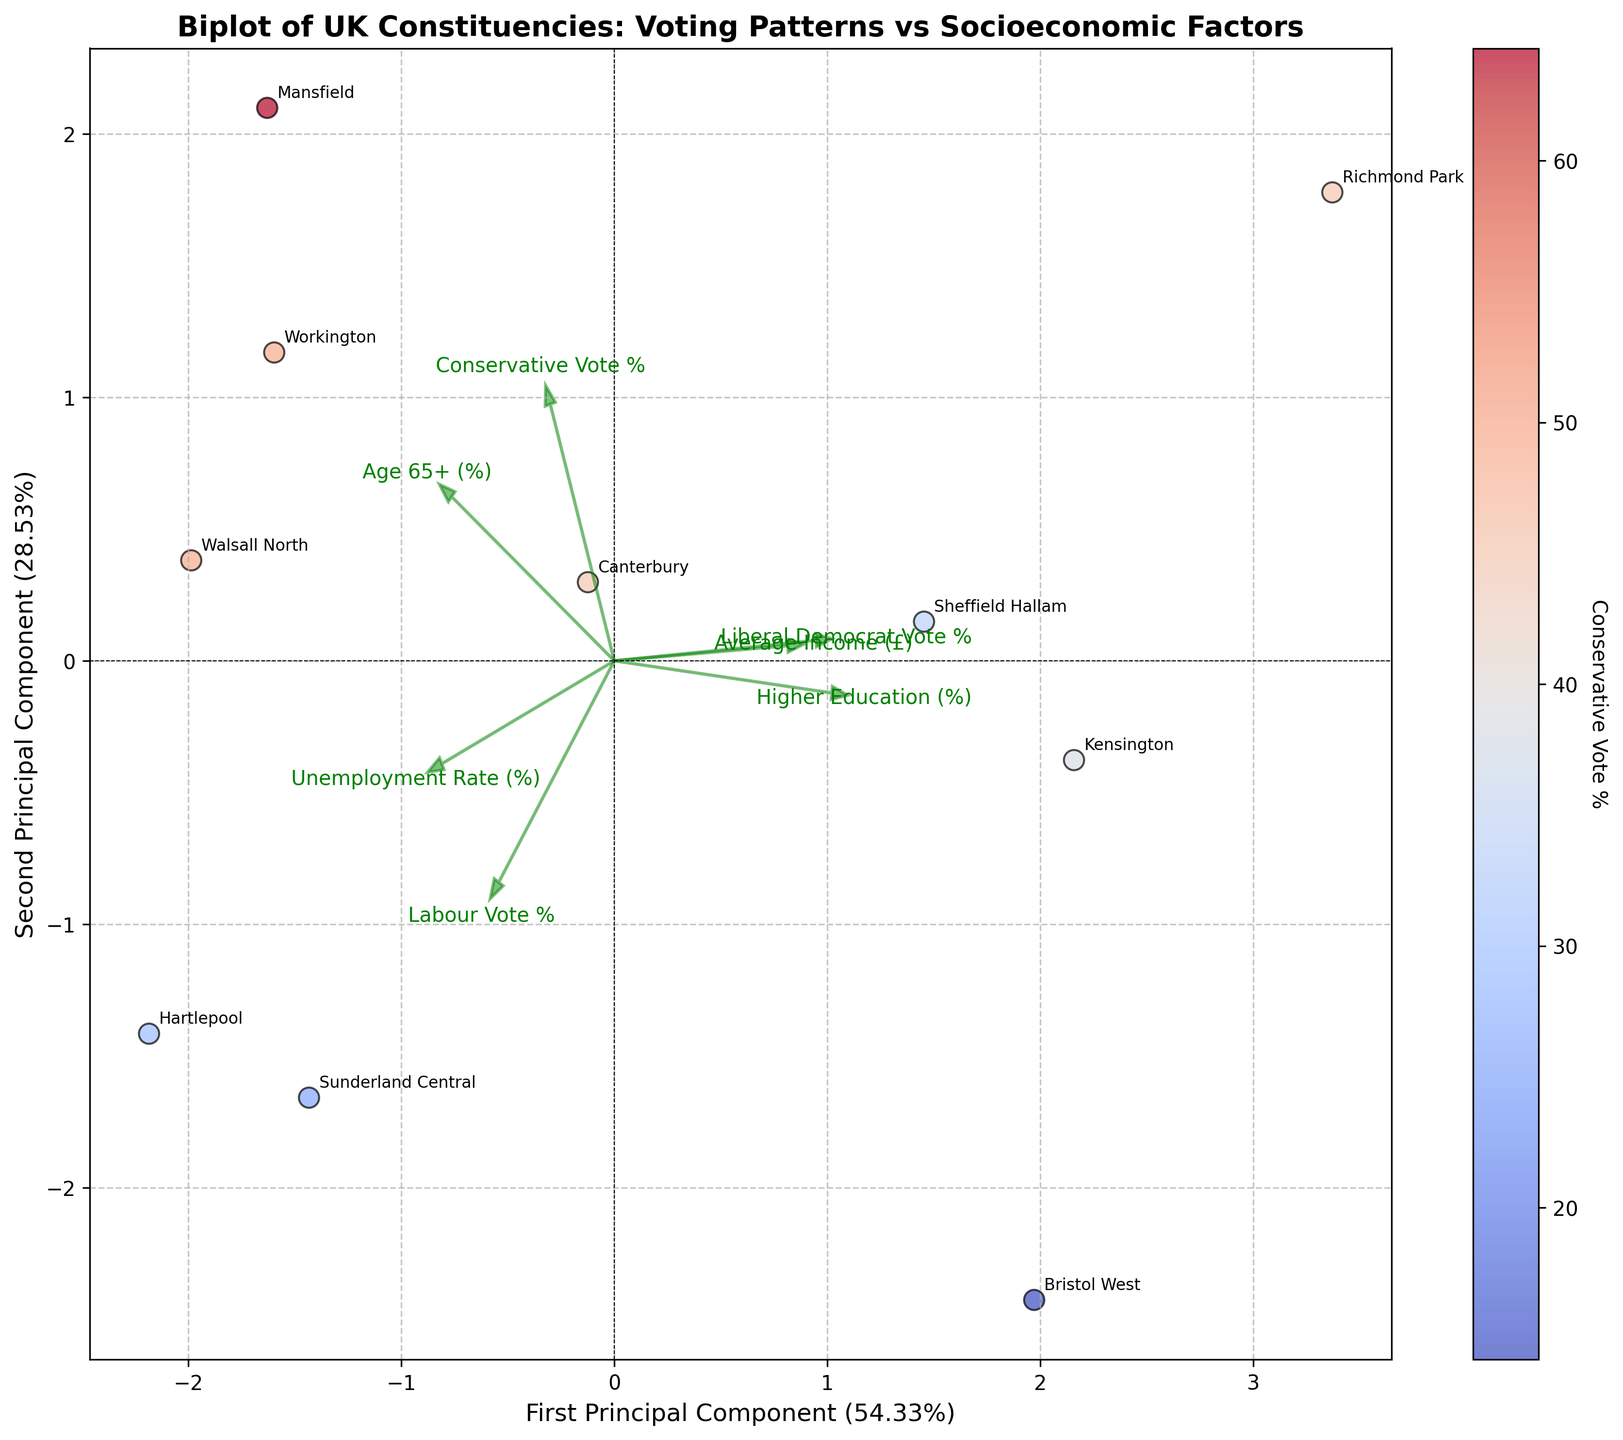What's the title of the plot? The title is usually prominently displayed at the top of the plot. This title helps to understand what the entire plot is about. The title for this plot is clearly written at the top as 'Biplot of UK Constituencies: Voting Patterns vs Socioeconomic Factors'.
Answer: Biplot of UK Constituencies: Voting Patterns vs Socioeconomic Factors How many principle components are shown on the axes? The axes are labeled with the terms 'First Principal Component' and 'Second Principal Component'. This indicates that two principal components are being visualized.
Answer: Two Which constituency has the highest Conservative Vote % based on the position on the colorbar? The colorbar indicates Conservative Vote %, which uses a color gradient. A darker color in the scatter plot corresponds to a higher Conservative Vote %. By looking at the plot, Mansfield has the highest Conservative Vote %.
Answer: Mansfield Which features are positively correlated with the First Principal Component axis? Positive correlation with the First Principal Component can be inferred from arrows pointing rightward or vectors along the positive side of the x-axis. For example, 'Conservative Vote %' and 'Higher Education (%)' arrows point in the positive direction along this axis.
Answer: Conservative Vote %, Higher Education (%) Which socioeconomic factor has the strongest influence on the First Principal Component? The length and direction of the arrows in the biplot represent the influence of a feature on a principal component. The longer the arrow, the higher the influence. The longest arrows along the First Principal Component axis indicate that 'Conservative Vote %' has the strongest influence.
Answer: Conservative Vote % Which constituency is located closest to the origin of the biplot, indicating average characteristics? Constituencies closer to the origin (where the two principal components intersect) have more average values across the considered features. By visually inspecting the plot, Sheffield Hallam is closest to the origin.
Answer: Sheffield Hallam How does the Age 65+ (%) factor relate to the socioeconomic factors and voting patterns in this biplot? The arrow for 'Age 65+ (%)' pointing slightly upward and left indicates a positive correlation with the Second Principal Component and a negative correlation with the First Principal Component. This means constituencies with a higher percentage of age 65+ generally have lower Conservative Votes % and are more influenced by other socioeconomic factors.
Answer: Higher age 65+ means lower Conservative Votes % Which constituencies have similar voting patterns according to this biplot? Constituencies that cluster together in the biplot have similar voting patterns. For example, Canterbury and Kensington appear close together, indicating similarity in their voting and socioeconomic characteristics.
Answer: Canterbury and Kensington What's the main insight provided by plotting Liberal Democrat Vote % on the biplot? The direction and length of the 'Liberal Democrat Vote %' arrow can show its correlation with the principal components. It points downwards and slightly to the right, indicating a negative correlation with the Second Principal Component and a slight positive one with the First. This suggests that Liberal Democrat Votes increase as some of the other factors decrease.
Answer: Liberal Democrats increase as some factors decrease Which feature vectors are negatively correlated with each other? Negative correlation between features can be inferred from their arrows pointing in opposite directions. For instance, 'Labour Vote %' and 'Higher Education (%)' arrows are almost opposite, suggesting a negative correlation.
Answer: Labour Vote % and Higher Education (%) 